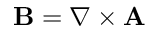<formula> <loc_0><loc_0><loc_500><loc_500>B = \nabla \times A</formula> 